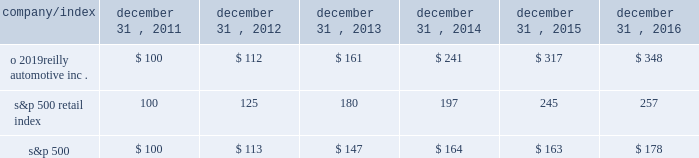Stock performance graph : the graph below shows the cumulative total shareholder return assuming the investment of $ 100 , on december 31 , 2011 , and the reinvestment of dividends thereafter , if any , in the company 2019s common stock versus the standard and poor 2019s s&p 500 retail index ( 201cs&p 500 retail index 201d ) and the standard and poor 2019s s&p 500 index ( 201cs&p 500 201d ) . .

What is the total return generated if $ 10 million are invested in s&p500 in 2011 and sold in 2013 , in millions? 
Computations: (((147 - 100) / 100) * 10)
Answer: 4.7. 